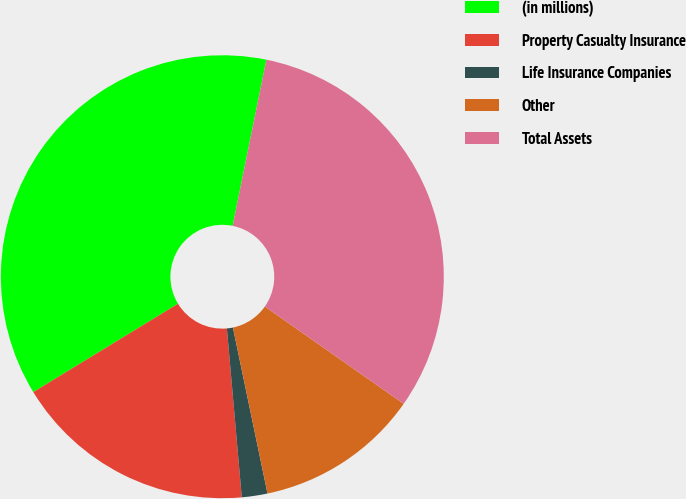Convert chart to OTSL. <chart><loc_0><loc_0><loc_500><loc_500><pie_chart><fcel>(in millions)<fcel>Property Casualty Insurance<fcel>Life Insurance Companies<fcel>Other<fcel>Total Assets<nl><fcel>36.91%<fcel>17.68%<fcel>1.87%<fcel>12.0%<fcel>31.54%<nl></chart> 